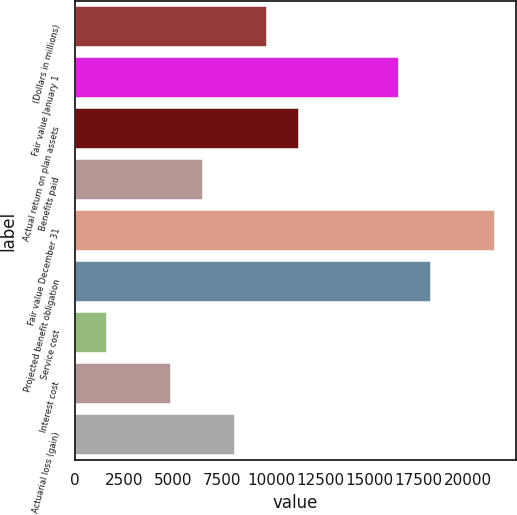<chart> <loc_0><loc_0><loc_500><loc_500><bar_chart><fcel>(Dollars in millions)<fcel>Fair value January 1<fcel>Actual return on plan assets<fcel>Benefits paid<fcel>Fair value December 31<fcel>Projected benefit obligation<fcel>Service cost<fcel>Interest cost<fcel>Actuarial loss (gain)<nl><fcel>9766<fcel>16518<fcel>11393<fcel>6512<fcel>21399<fcel>18145<fcel>1631<fcel>4885<fcel>8139<nl></chart> 